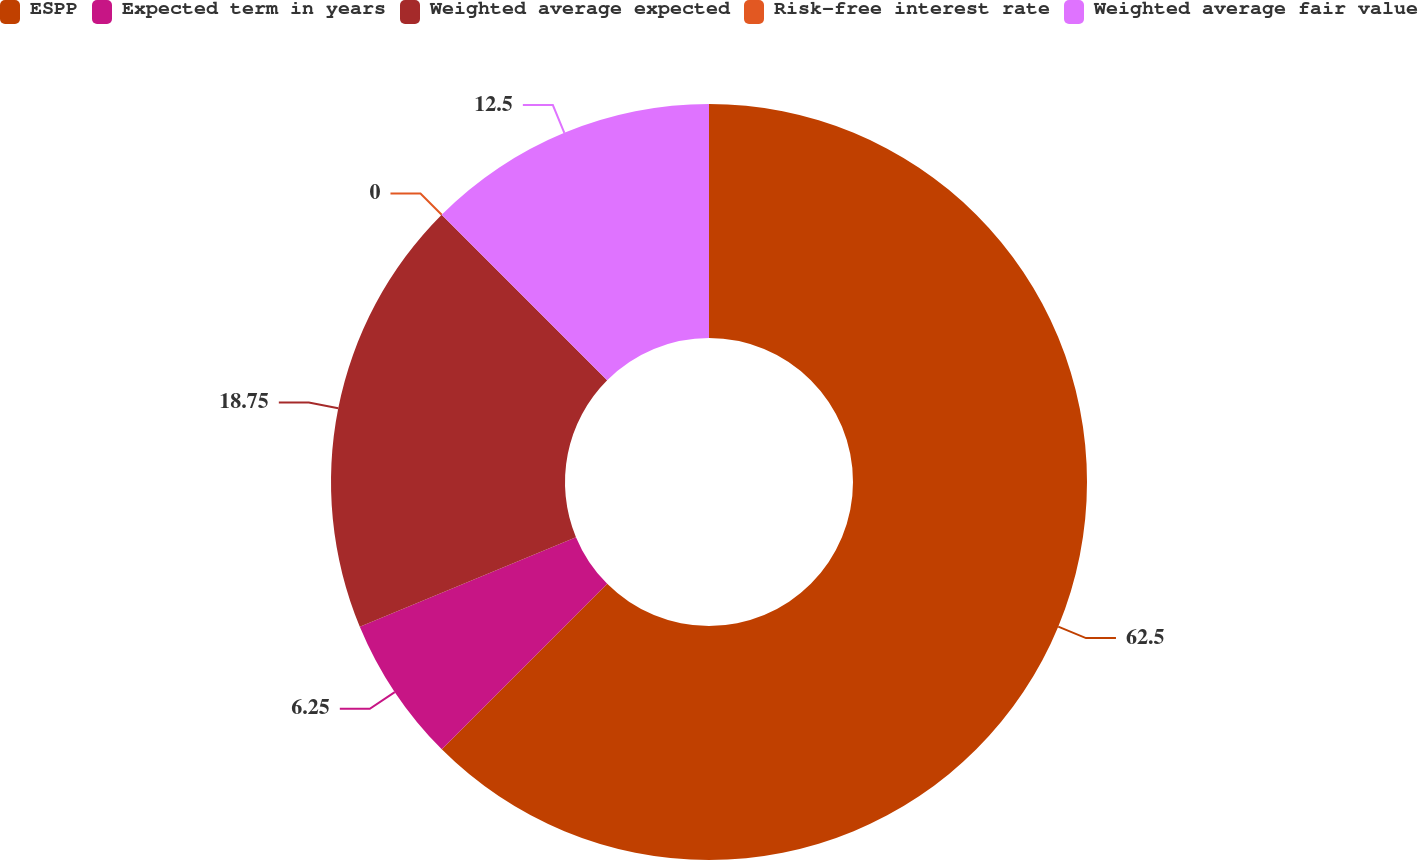Convert chart to OTSL. <chart><loc_0><loc_0><loc_500><loc_500><pie_chart><fcel>ESPP<fcel>Expected term in years<fcel>Weighted average expected<fcel>Risk-free interest rate<fcel>Weighted average fair value<nl><fcel>62.49%<fcel>6.25%<fcel>18.75%<fcel>0.0%<fcel>12.5%<nl></chart> 